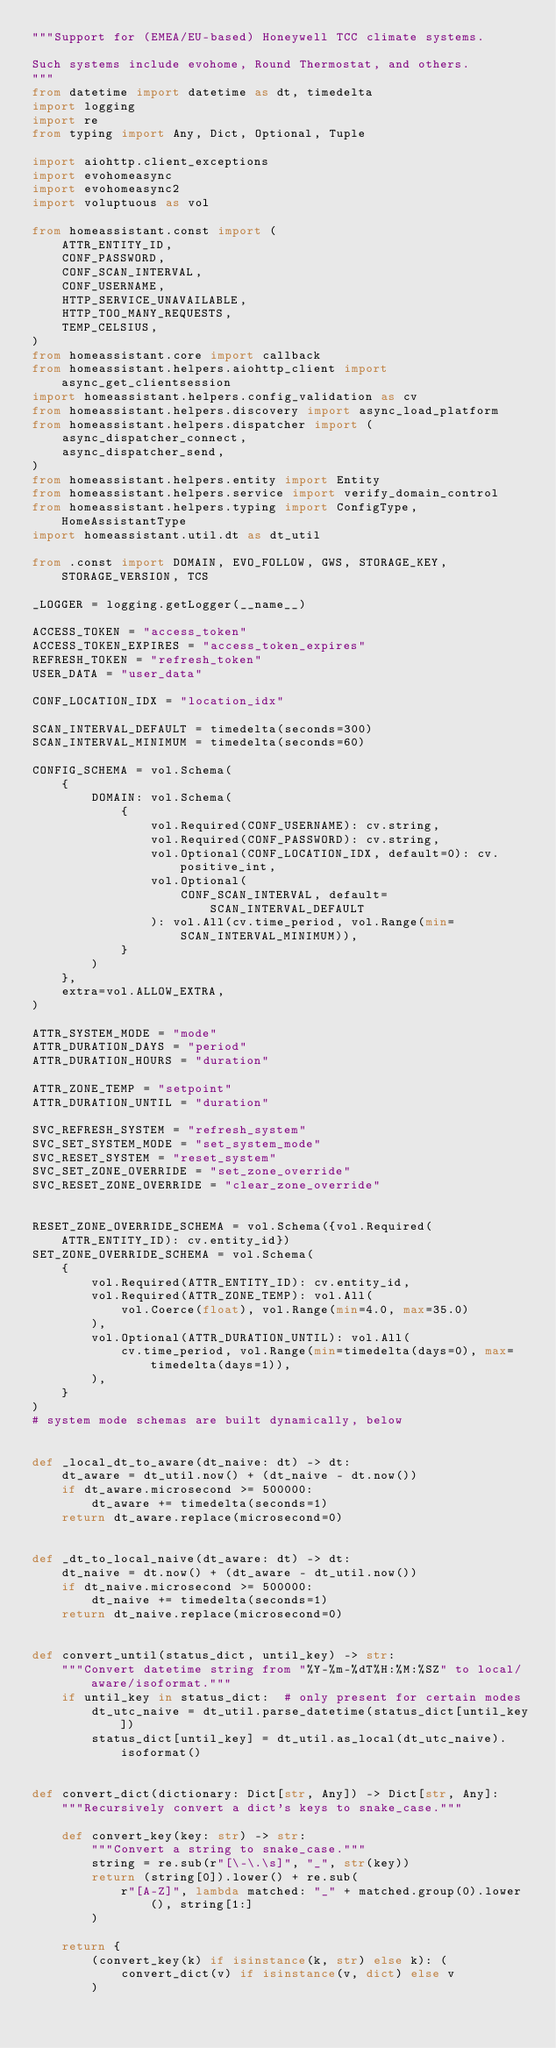<code> <loc_0><loc_0><loc_500><loc_500><_Python_>"""Support for (EMEA/EU-based) Honeywell TCC climate systems.

Such systems include evohome, Round Thermostat, and others.
"""
from datetime import datetime as dt, timedelta
import logging
import re
from typing import Any, Dict, Optional, Tuple

import aiohttp.client_exceptions
import evohomeasync
import evohomeasync2
import voluptuous as vol

from homeassistant.const import (
    ATTR_ENTITY_ID,
    CONF_PASSWORD,
    CONF_SCAN_INTERVAL,
    CONF_USERNAME,
    HTTP_SERVICE_UNAVAILABLE,
    HTTP_TOO_MANY_REQUESTS,
    TEMP_CELSIUS,
)
from homeassistant.core import callback
from homeassistant.helpers.aiohttp_client import async_get_clientsession
import homeassistant.helpers.config_validation as cv
from homeassistant.helpers.discovery import async_load_platform
from homeassistant.helpers.dispatcher import (
    async_dispatcher_connect,
    async_dispatcher_send,
)
from homeassistant.helpers.entity import Entity
from homeassistant.helpers.service import verify_domain_control
from homeassistant.helpers.typing import ConfigType, HomeAssistantType
import homeassistant.util.dt as dt_util

from .const import DOMAIN, EVO_FOLLOW, GWS, STORAGE_KEY, STORAGE_VERSION, TCS

_LOGGER = logging.getLogger(__name__)

ACCESS_TOKEN = "access_token"
ACCESS_TOKEN_EXPIRES = "access_token_expires"
REFRESH_TOKEN = "refresh_token"
USER_DATA = "user_data"

CONF_LOCATION_IDX = "location_idx"

SCAN_INTERVAL_DEFAULT = timedelta(seconds=300)
SCAN_INTERVAL_MINIMUM = timedelta(seconds=60)

CONFIG_SCHEMA = vol.Schema(
    {
        DOMAIN: vol.Schema(
            {
                vol.Required(CONF_USERNAME): cv.string,
                vol.Required(CONF_PASSWORD): cv.string,
                vol.Optional(CONF_LOCATION_IDX, default=0): cv.positive_int,
                vol.Optional(
                    CONF_SCAN_INTERVAL, default=SCAN_INTERVAL_DEFAULT
                ): vol.All(cv.time_period, vol.Range(min=SCAN_INTERVAL_MINIMUM)),
            }
        )
    },
    extra=vol.ALLOW_EXTRA,
)

ATTR_SYSTEM_MODE = "mode"
ATTR_DURATION_DAYS = "period"
ATTR_DURATION_HOURS = "duration"

ATTR_ZONE_TEMP = "setpoint"
ATTR_DURATION_UNTIL = "duration"

SVC_REFRESH_SYSTEM = "refresh_system"
SVC_SET_SYSTEM_MODE = "set_system_mode"
SVC_RESET_SYSTEM = "reset_system"
SVC_SET_ZONE_OVERRIDE = "set_zone_override"
SVC_RESET_ZONE_OVERRIDE = "clear_zone_override"


RESET_ZONE_OVERRIDE_SCHEMA = vol.Schema({vol.Required(ATTR_ENTITY_ID): cv.entity_id})
SET_ZONE_OVERRIDE_SCHEMA = vol.Schema(
    {
        vol.Required(ATTR_ENTITY_ID): cv.entity_id,
        vol.Required(ATTR_ZONE_TEMP): vol.All(
            vol.Coerce(float), vol.Range(min=4.0, max=35.0)
        ),
        vol.Optional(ATTR_DURATION_UNTIL): vol.All(
            cv.time_period, vol.Range(min=timedelta(days=0), max=timedelta(days=1)),
        ),
    }
)
# system mode schemas are built dynamically, below


def _local_dt_to_aware(dt_naive: dt) -> dt:
    dt_aware = dt_util.now() + (dt_naive - dt.now())
    if dt_aware.microsecond >= 500000:
        dt_aware += timedelta(seconds=1)
    return dt_aware.replace(microsecond=0)


def _dt_to_local_naive(dt_aware: dt) -> dt:
    dt_naive = dt.now() + (dt_aware - dt_util.now())
    if dt_naive.microsecond >= 500000:
        dt_naive += timedelta(seconds=1)
    return dt_naive.replace(microsecond=0)


def convert_until(status_dict, until_key) -> str:
    """Convert datetime string from "%Y-%m-%dT%H:%M:%SZ" to local/aware/isoformat."""
    if until_key in status_dict:  # only present for certain modes
        dt_utc_naive = dt_util.parse_datetime(status_dict[until_key])
        status_dict[until_key] = dt_util.as_local(dt_utc_naive).isoformat()


def convert_dict(dictionary: Dict[str, Any]) -> Dict[str, Any]:
    """Recursively convert a dict's keys to snake_case."""

    def convert_key(key: str) -> str:
        """Convert a string to snake_case."""
        string = re.sub(r"[\-\.\s]", "_", str(key))
        return (string[0]).lower() + re.sub(
            r"[A-Z]", lambda matched: "_" + matched.group(0).lower(), string[1:]
        )

    return {
        (convert_key(k) if isinstance(k, str) else k): (
            convert_dict(v) if isinstance(v, dict) else v
        )</code> 